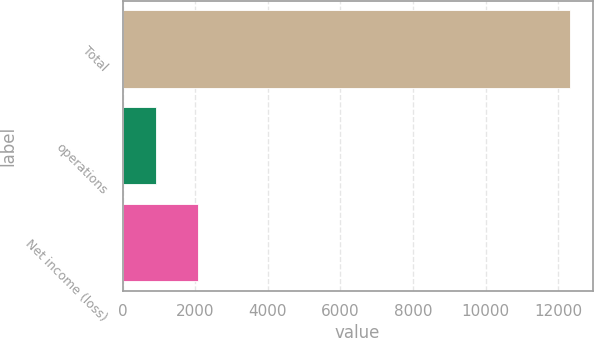Convert chart to OTSL. <chart><loc_0><loc_0><loc_500><loc_500><bar_chart><fcel>Total<fcel>operations<fcel>Net income (loss)<nl><fcel>12332<fcel>930<fcel>2070.2<nl></chart> 